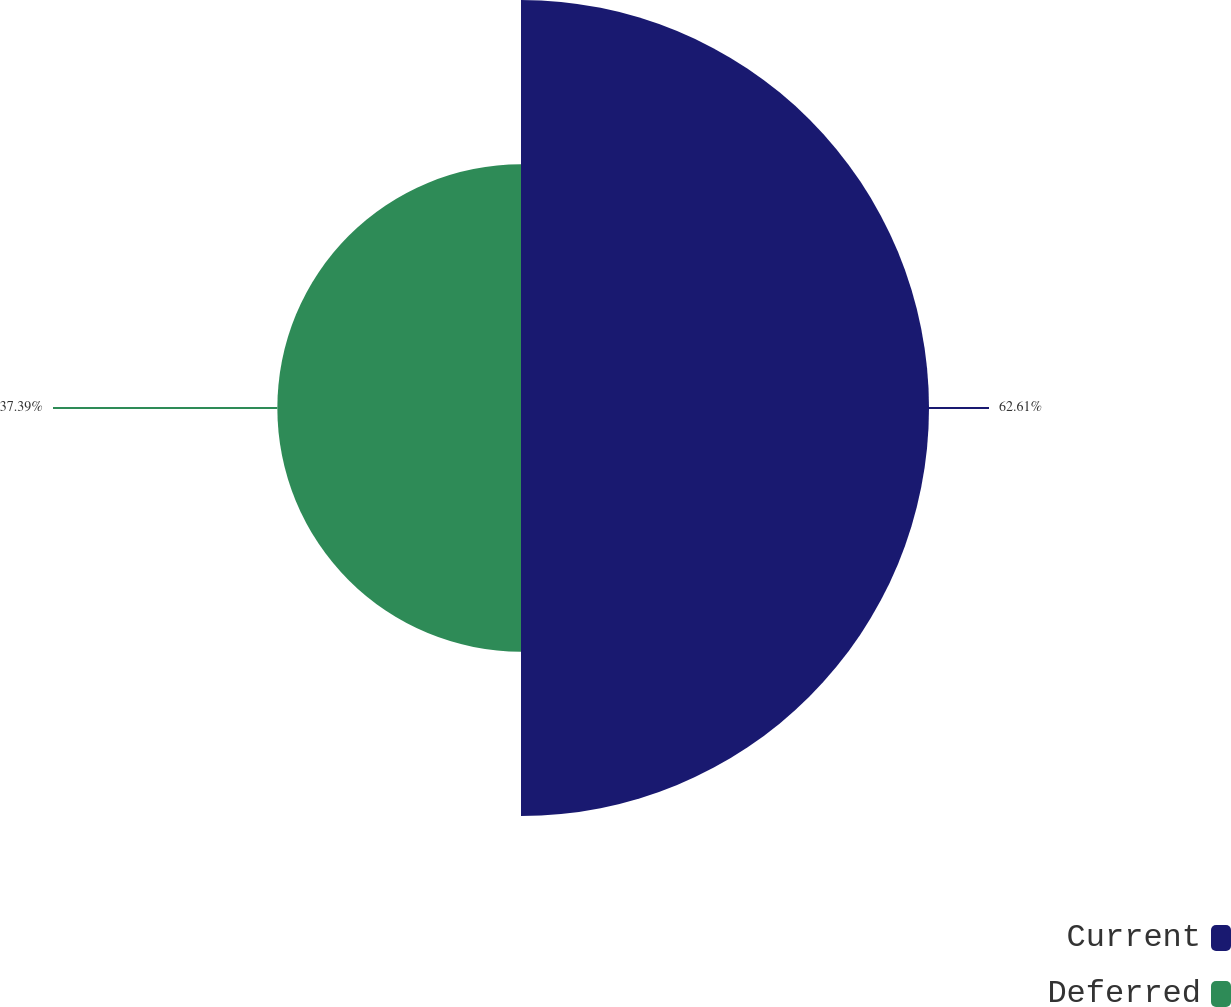Convert chart. <chart><loc_0><loc_0><loc_500><loc_500><pie_chart><fcel>Current<fcel>Deferred<nl><fcel>62.61%<fcel>37.39%<nl></chart> 